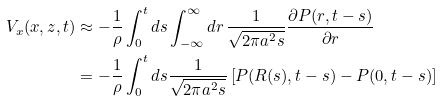Convert formula to latex. <formula><loc_0><loc_0><loc_500><loc_500>V _ { x } ( x , z , t ) & \approx - \frac { 1 } { \rho } \int _ { 0 } ^ { t } d s \int _ { - \infty } ^ { \infty } d r \, \frac { 1 } { \sqrt { 2 \pi a ^ { 2 } s } } \frac { \partial P ( r , t - s ) } { \partial r } \\ & = - \frac { 1 } { \rho } \int _ { 0 } ^ { t } d s \frac { 1 } { \sqrt { 2 \pi a ^ { 2 } s } } \left [ P ( R ( s ) , t - s ) - P ( 0 , t - s ) \right ]</formula> 